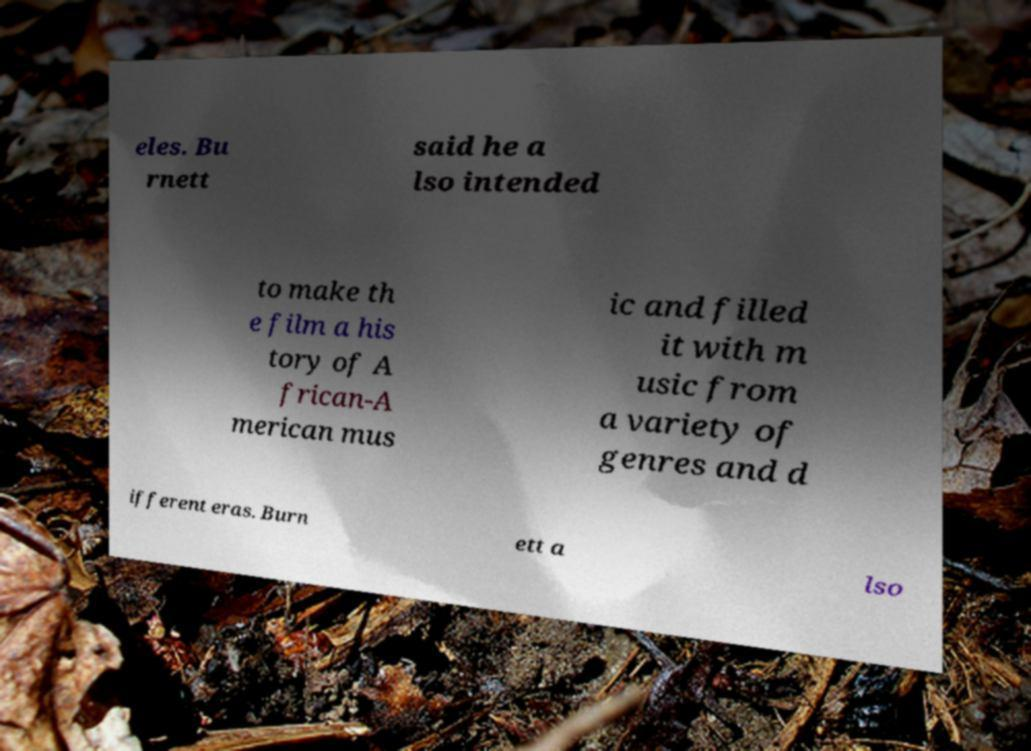Could you extract and type out the text from this image? eles. Bu rnett said he a lso intended to make th e film a his tory of A frican-A merican mus ic and filled it with m usic from a variety of genres and d ifferent eras. Burn ett a lso 